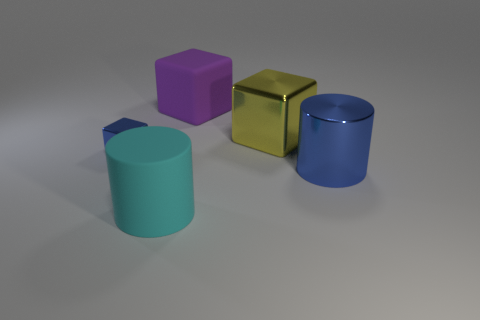Add 4 big blue metallic balls. How many objects exist? 9 Subtract all big purple rubber blocks. How many blocks are left? 2 Subtract 2 blocks. How many blocks are left? 1 Subtract all blocks. How many objects are left? 2 Subtract 1 purple cubes. How many objects are left? 4 Subtract all red cylinders. Subtract all brown balls. How many cylinders are left? 2 Subtract all small metallic objects. Subtract all big purple rubber things. How many objects are left? 3 Add 1 large cyan rubber cylinders. How many large cyan rubber cylinders are left? 2 Add 1 large cyan rubber cylinders. How many large cyan rubber cylinders exist? 2 Subtract all yellow blocks. How many blocks are left? 2 